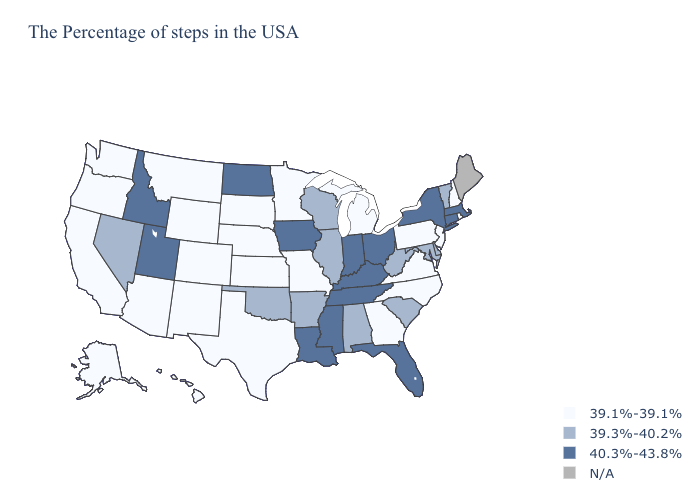What is the value of Virginia?
Concise answer only. 39.1%-39.1%. Which states hav the highest value in the Northeast?
Keep it brief. Massachusetts, Connecticut, New York. What is the lowest value in the USA?
Keep it brief. 39.1%-39.1%. Does Kansas have the highest value in the USA?
Give a very brief answer. No. What is the highest value in the USA?
Be succinct. 40.3%-43.8%. Name the states that have a value in the range 40.3%-43.8%?
Write a very short answer. Massachusetts, Connecticut, New York, Ohio, Florida, Kentucky, Indiana, Tennessee, Mississippi, Louisiana, Iowa, North Dakota, Utah, Idaho. Name the states that have a value in the range N/A?
Write a very short answer. Maine. Name the states that have a value in the range N/A?
Keep it brief. Maine. What is the value of Louisiana?
Be succinct. 40.3%-43.8%. Does the map have missing data?
Concise answer only. Yes. What is the value of Connecticut?
Be succinct. 40.3%-43.8%. Does the map have missing data?
Keep it brief. Yes. What is the value of Florida?
Write a very short answer. 40.3%-43.8%. 